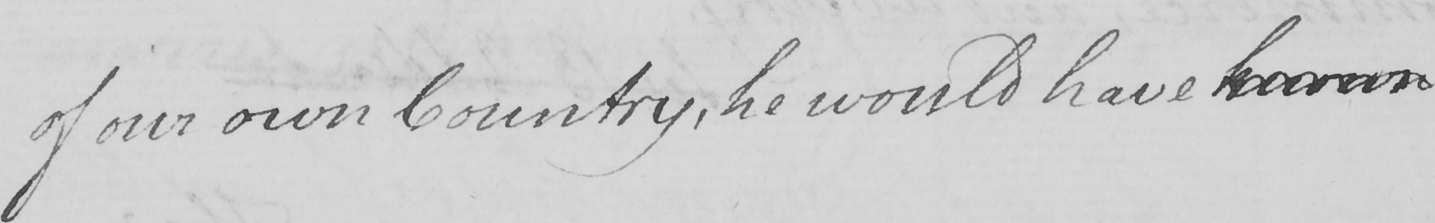Can you read and transcribe this handwriting? of our own country , he would have known 